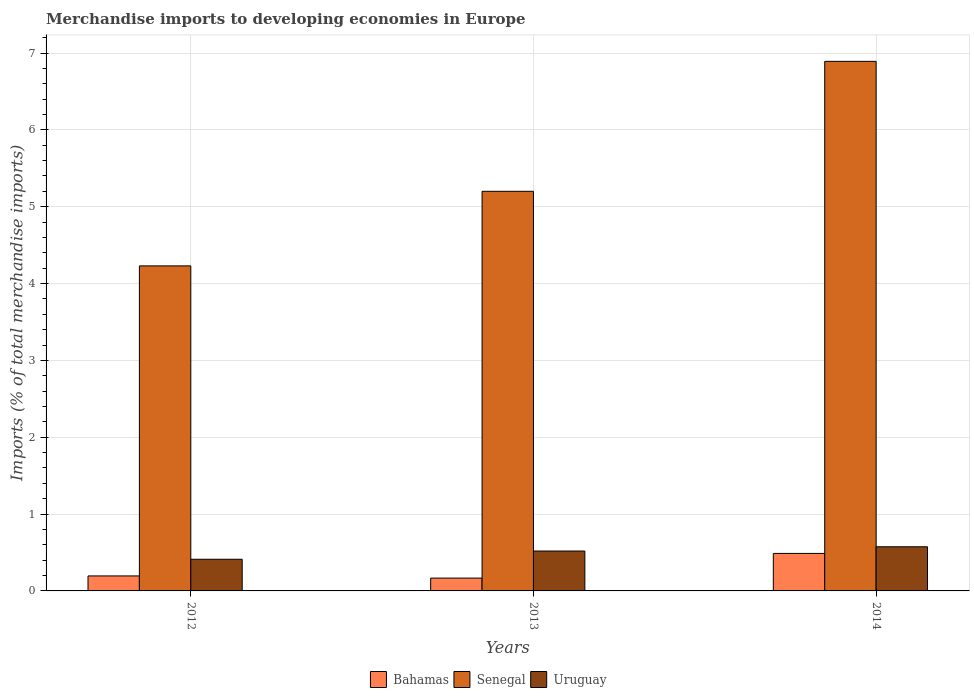Are the number of bars per tick equal to the number of legend labels?
Offer a very short reply. Yes. In how many cases, is the number of bars for a given year not equal to the number of legend labels?
Your answer should be very brief. 0. What is the percentage total merchandise imports in Senegal in 2014?
Offer a very short reply. 6.89. Across all years, what is the maximum percentage total merchandise imports in Uruguay?
Make the answer very short. 0.57. Across all years, what is the minimum percentage total merchandise imports in Senegal?
Ensure brevity in your answer.  4.23. In which year was the percentage total merchandise imports in Senegal maximum?
Your response must be concise. 2014. In which year was the percentage total merchandise imports in Bahamas minimum?
Your answer should be very brief. 2013. What is the total percentage total merchandise imports in Senegal in the graph?
Offer a very short reply. 16.32. What is the difference between the percentage total merchandise imports in Senegal in 2012 and that in 2013?
Ensure brevity in your answer.  -0.97. What is the difference between the percentage total merchandise imports in Senegal in 2014 and the percentage total merchandise imports in Bahamas in 2013?
Offer a terse response. 6.73. What is the average percentage total merchandise imports in Uruguay per year?
Make the answer very short. 0.5. In the year 2012, what is the difference between the percentage total merchandise imports in Uruguay and percentage total merchandise imports in Senegal?
Provide a succinct answer. -3.82. What is the ratio of the percentage total merchandise imports in Senegal in 2013 to that in 2014?
Offer a very short reply. 0.75. What is the difference between the highest and the second highest percentage total merchandise imports in Bahamas?
Keep it short and to the point. 0.29. What is the difference between the highest and the lowest percentage total merchandise imports in Bahamas?
Your answer should be very brief. 0.32. In how many years, is the percentage total merchandise imports in Bahamas greater than the average percentage total merchandise imports in Bahamas taken over all years?
Keep it short and to the point. 1. Is the sum of the percentage total merchandise imports in Uruguay in 2013 and 2014 greater than the maximum percentage total merchandise imports in Senegal across all years?
Your answer should be very brief. No. What does the 1st bar from the left in 2013 represents?
Offer a very short reply. Bahamas. What does the 1st bar from the right in 2012 represents?
Your response must be concise. Uruguay. Are all the bars in the graph horizontal?
Your response must be concise. No. What is the difference between two consecutive major ticks on the Y-axis?
Give a very brief answer. 1. Does the graph contain any zero values?
Ensure brevity in your answer.  No. Where does the legend appear in the graph?
Provide a short and direct response. Bottom center. What is the title of the graph?
Make the answer very short. Merchandise imports to developing economies in Europe. What is the label or title of the Y-axis?
Offer a very short reply. Imports (% of total merchandise imports). What is the Imports (% of total merchandise imports) of Bahamas in 2012?
Your response must be concise. 0.2. What is the Imports (% of total merchandise imports) of Senegal in 2012?
Offer a terse response. 4.23. What is the Imports (% of total merchandise imports) of Uruguay in 2012?
Offer a very short reply. 0.41. What is the Imports (% of total merchandise imports) of Bahamas in 2013?
Give a very brief answer. 0.17. What is the Imports (% of total merchandise imports) in Senegal in 2013?
Give a very brief answer. 5.2. What is the Imports (% of total merchandise imports) of Uruguay in 2013?
Offer a terse response. 0.52. What is the Imports (% of total merchandise imports) of Bahamas in 2014?
Your answer should be very brief. 0.49. What is the Imports (% of total merchandise imports) in Senegal in 2014?
Make the answer very short. 6.89. What is the Imports (% of total merchandise imports) in Uruguay in 2014?
Make the answer very short. 0.57. Across all years, what is the maximum Imports (% of total merchandise imports) in Bahamas?
Give a very brief answer. 0.49. Across all years, what is the maximum Imports (% of total merchandise imports) of Senegal?
Provide a short and direct response. 6.89. Across all years, what is the maximum Imports (% of total merchandise imports) of Uruguay?
Provide a short and direct response. 0.57. Across all years, what is the minimum Imports (% of total merchandise imports) in Bahamas?
Give a very brief answer. 0.17. Across all years, what is the minimum Imports (% of total merchandise imports) in Senegal?
Your response must be concise. 4.23. Across all years, what is the minimum Imports (% of total merchandise imports) in Uruguay?
Provide a short and direct response. 0.41. What is the total Imports (% of total merchandise imports) in Bahamas in the graph?
Offer a very short reply. 0.85. What is the total Imports (% of total merchandise imports) in Senegal in the graph?
Your response must be concise. 16.32. What is the total Imports (% of total merchandise imports) of Uruguay in the graph?
Give a very brief answer. 1.51. What is the difference between the Imports (% of total merchandise imports) in Bahamas in 2012 and that in 2013?
Your answer should be compact. 0.03. What is the difference between the Imports (% of total merchandise imports) of Senegal in 2012 and that in 2013?
Your answer should be compact. -0.97. What is the difference between the Imports (% of total merchandise imports) of Uruguay in 2012 and that in 2013?
Your answer should be very brief. -0.11. What is the difference between the Imports (% of total merchandise imports) of Bahamas in 2012 and that in 2014?
Provide a short and direct response. -0.29. What is the difference between the Imports (% of total merchandise imports) of Senegal in 2012 and that in 2014?
Keep it short and to the point. -2.66. What is the difference between the Imports (% of total merchandise imports) in Uruguay in 2012 and that in 2014?
Make the answer very short. -0.16. What is the difference between the Imports (% of total merchandise imports) in Bahamas in 2013 and that in 2014?
Your answer should be compact. -0.32. What is the difference between the Imports (% of total merchandise imports) in Senegal in 2013 and that in 2014?
Offer a very short reply. -1.69. What is the difference between the Imports (% of total merchandise imports) of Uruguay in 2013 and that in 2014?
Offer a terse response. -0.06. What is the difference between the Imports (% of total merchandise imports) in Bahamas in 2012 and the Imports (% of total merchandise imports) in Senegal in 2013?
Make the answer very short. -5.01. What is the difference between the Imports (% of total merchandise imports) of Bahamas in 2012 and the Imports (% of total merchandise imports) of Uruguay in 2013?
Ensure brevity in your answer.  -0.32. What is the difference between the Imports (% of total merchandise imports) in Senegal in 2012 and the Imports (% of total merchandise imports) in Uruguay in 2013?
Keep it short and to the point. 3.71. What is the difference between the Imports (% of total merchandise imports) of Bahamas in 2012 and the Imports (% of total merchandise imports) of Senegal in 2014?
Make the answer very short. -6.7. What is the difference between the Imports (% of total merchandise imports) of Bahamas in 2012 and the Imports (% of total merchandise imports) of Uruguay in 2014?
Provide a succinct answer. -0.38. What is the difference between the Imports (% of total merchandise imports) in Senegal in 2012 and the Imports (% of total merchandise imports) in Uruguay in 2014?
Ensure brevity in your answer.  3.66. What is the difference between the Imports (% of total merchandise imports) of Bahamas in 2013 and the Imports (% of total merchandise imports) of Senegal in 2014?
Your answer should be very brief. -6.73. What is the difference between the Imports (% of total merchandise imports) in Bahamas in 2013 and the Imports (% of total merchandise imports) in Uruguay in 2014?
Give a very brief answer. -0.41. What is the difference between the Imports (% of total merchandise imports) in Senegal in 2013 and the Imports (% of total merchandise imports) in Uruguay in 2014?
Your answer should be compact. 4.63. What is the average Imports (% of total merchandise imports) of Bahamas per year?
Provide a succinct answer. 0.28. What is the average Imports (% of total merchandise imports) in Senegal per year?
Provide a short and direct response. 5.44. What is the average Imports (% of total merchandise imports) of Uruguay per year?
Provide a succinct answer. 0.5. In the year 2012, what is the difference between the Imports (% of total merchandise imports) in Bahamas and Imports (% of total merchandise imports) in Senegal?
Keep it short and to the point. -4.04. In the year 2012, what is the difference between the Imports (% of total merchandise imports) of Bahamas and Imports (% of total merchandise imports) of Uruguay?
Provide a short and direct response. -0.22. In the year 2012, what is the difference between the Imports (% of total merchandise imports) of Senegal and Imports (% of total merchandise imports) of Uruguay?
Your answer should be compact. 3.82. In the year 2013, what is the difference between the Imports (% of total merchandise imports) of Bahamas and Imports (% of total merchandise imports) of Senegal?
Provide a succinct answer. -5.03. In the year 2013, what is the difference between the Imports (% of total merchandise imports) of Bahamas and Imports (% of total merchandise imports) of Uruguay?
Give a very brief answer. -0.35. In the year 2013, what is the difference between the Imports (% of total merchandise imports) of Senegal and Imports (% of total merchandise imports) of Uruguay?
Your answer should be compact. 4.68. In the year 2014, what is the difference between the Imports (% of total merchandise imports) in Bahamas and Imports (% of total merchandise imports) in Senegal?
Ensure brevity in your answer.  -6.4. In the year 2014, what is the difference between the Imports (% of total merchandise imports) of Bahamas and Imports (% of total merchandise imports) of Uruguay?
Offer a terse response. -0.09. In the year 2014, what is the difference between the Imports (% of total merchandise imports) of Senegal and Imports (% of total merchandise imports) of Uruguay?
Offer a terse response. 6.32. What is the ratio of the Imports (% of total merchandise imports) of Bahamas in 2012 to that in 2013?
Keep it short and to the point. 1.17. What is the ratio of the Imports (% of total merchandise imports) in Senegal in 2012 to that in 2013?
Your answer should be compact. 0.81. What is the ratio of the Imports (% of total merchandise imports) of Uruguay in 2012 to that in 2013?
Your response must be concise. 0.79. What is the ratio of the Imports (% of total merchandise imports) of Bahamas in 2012 to that in 2014?
Keep it short and to the point. 0.4. What is the ratio of the Imports (% of total merchandise imports) in Senegal in 2012 to that in 2014?
Offer a terse response. 0.61. What is the ratio of the Imports (% of total merchandise imports) in Uruguay in 2012 to that in 2014?
Keep it short and to the point. 0.72. What is the ratio of the Imports (% of total merchandise imports) in Bahamas in 2013 to that in 2014?
Offer a terse response. 0.34. What is the ratio of the Imports (% of total merchandise imports) in Senegal in 2013 to that in 2014?
Keep it short and to the point. 0.75. What is the ratio of the Imports (% of total merchandise imports) in Uruguay in 2013 to that in 2014?
Your response must be concise. 0.9. What is the difference between the highest and the second highest Imports (% of total merchandise imports) in Bahamas?
Offer a very short reply. 0.29. What is the difference between the highest and the second highest Imports (% of total merchandise imports) of Senegal?
Provide a succinct answer. 1.69. What is the difference between the highest and the second highest Imports (% of total merchandise imports) of Uruguay?
Make the answer very short. 0.06. What is the difference between the highest and the lowest Imports (% of total merchandise imports) of Bahamas?
Keep it short and to the point. 0.32. What is the difference between the highest and the lowest Imports (% of total merchandise imports) in Senegal?
Ensure brevity in your answer.  2.66. What is the difference between the highest and the lowest Imports (% of total merchandise imports) in Uruguay?
Give a very brief answer. 0.16. 